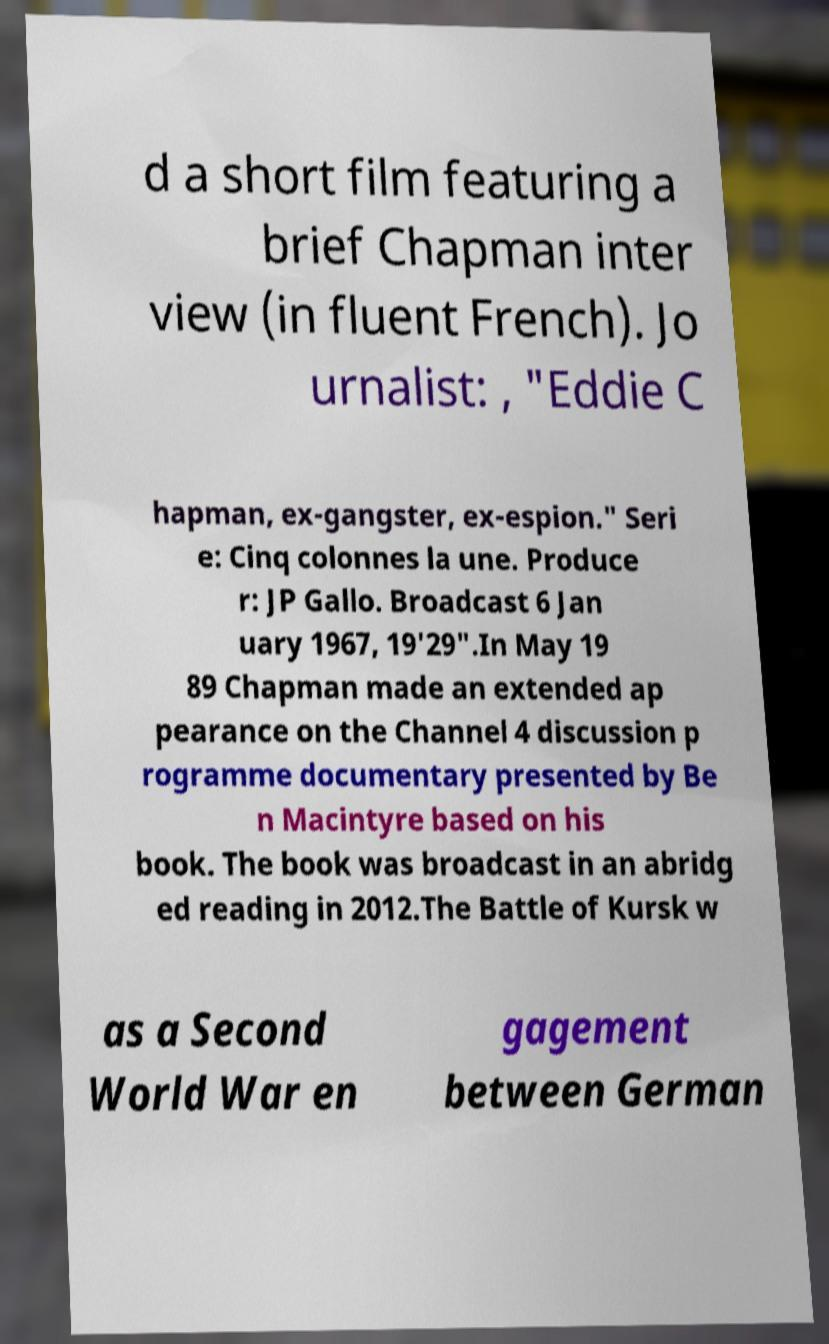Can you read and provide the text displayed in the image?This photo seems to have some interesting text. Can you extract and type it out for me? d a short film featuring a brief Chapman inter view (in fluent French). Jo urnalist: , "Eddie C hapman, ex-gangster, ex-espion." Seri e: Cinq colonnes la une. Produce r: JP Gallo. Broadcast 6 Jan uary 1967, 19'29".In May 19 89 Chapman made an extended ap pearance on the Channel 4 discussion p rogramme documentary presented by Be n Macintyre based on his book. The book was broadcast in an abridg ed reading in 2012.The Battle of Kursk w as a Second World War en gagement between German 